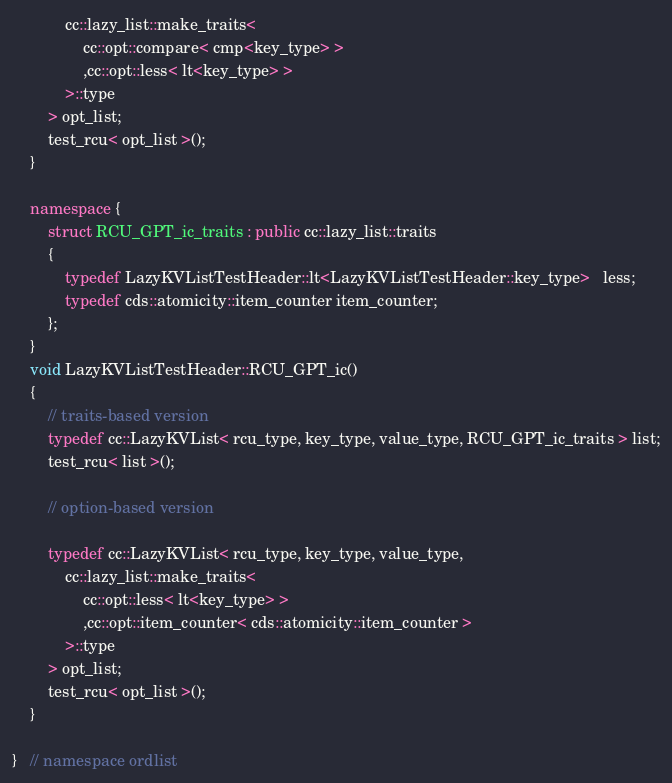<code> <loc_0><loc_0><loc_500><loc_500><_C++_>            cc::lazy_list::make_traits<
                cc::opt::compare< cmp<key_type> >
                ,cc::opt::less< lt<key_type> >
            >::type
        > opt_list;
        test_rcu< opt_list >();
    }

    namespace {
        struct RCU_GPT_ic_traits : public cc::lazy_list::traits
        {
            typedef LazyKVListTestHeader::lt<LazyKVListTestHeader::key_type>   less;
            typedef cds::atomicity::item_counter item_counter;
        };
    }
    void LazyKVListTestHeader::RCU_GPT_ic()
    {
        // traits-based version
        typedef cc::LazyKVList< rcu_type, key_type, value_type, RCU_GPT_ic_traits > list;
        test_rcu< list >();

        // option-based version

        typedef cc::LazyKVList< rcu_type, key_type, value_type,
            cc::lazy_list::make_traits<
                cc::opt::less< lt<key_type> >
                ,cc::opt::item_counter< cds::atomicity::item_counter >
            >::type
        > opt_list;
        test_rcu< opt_list >();
    }

}   // namespace ordlist

</code> 